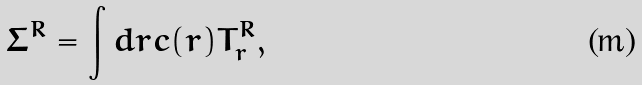<formula> <loc_0><loc_0><loc_500><loc_500>\Sigma ^ { R } = \int d r c ( r ) T ^ { R } _ { r } ,</formula> 